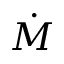Convert formula to latex. <formula><loc_0><loc_0><loc_500><loc_500>\dot { M }</formula> 